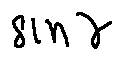Convert formula to latex. <formula><loc_0><loc_0><loc_500><loc_500>\sin \gamma</formula> 